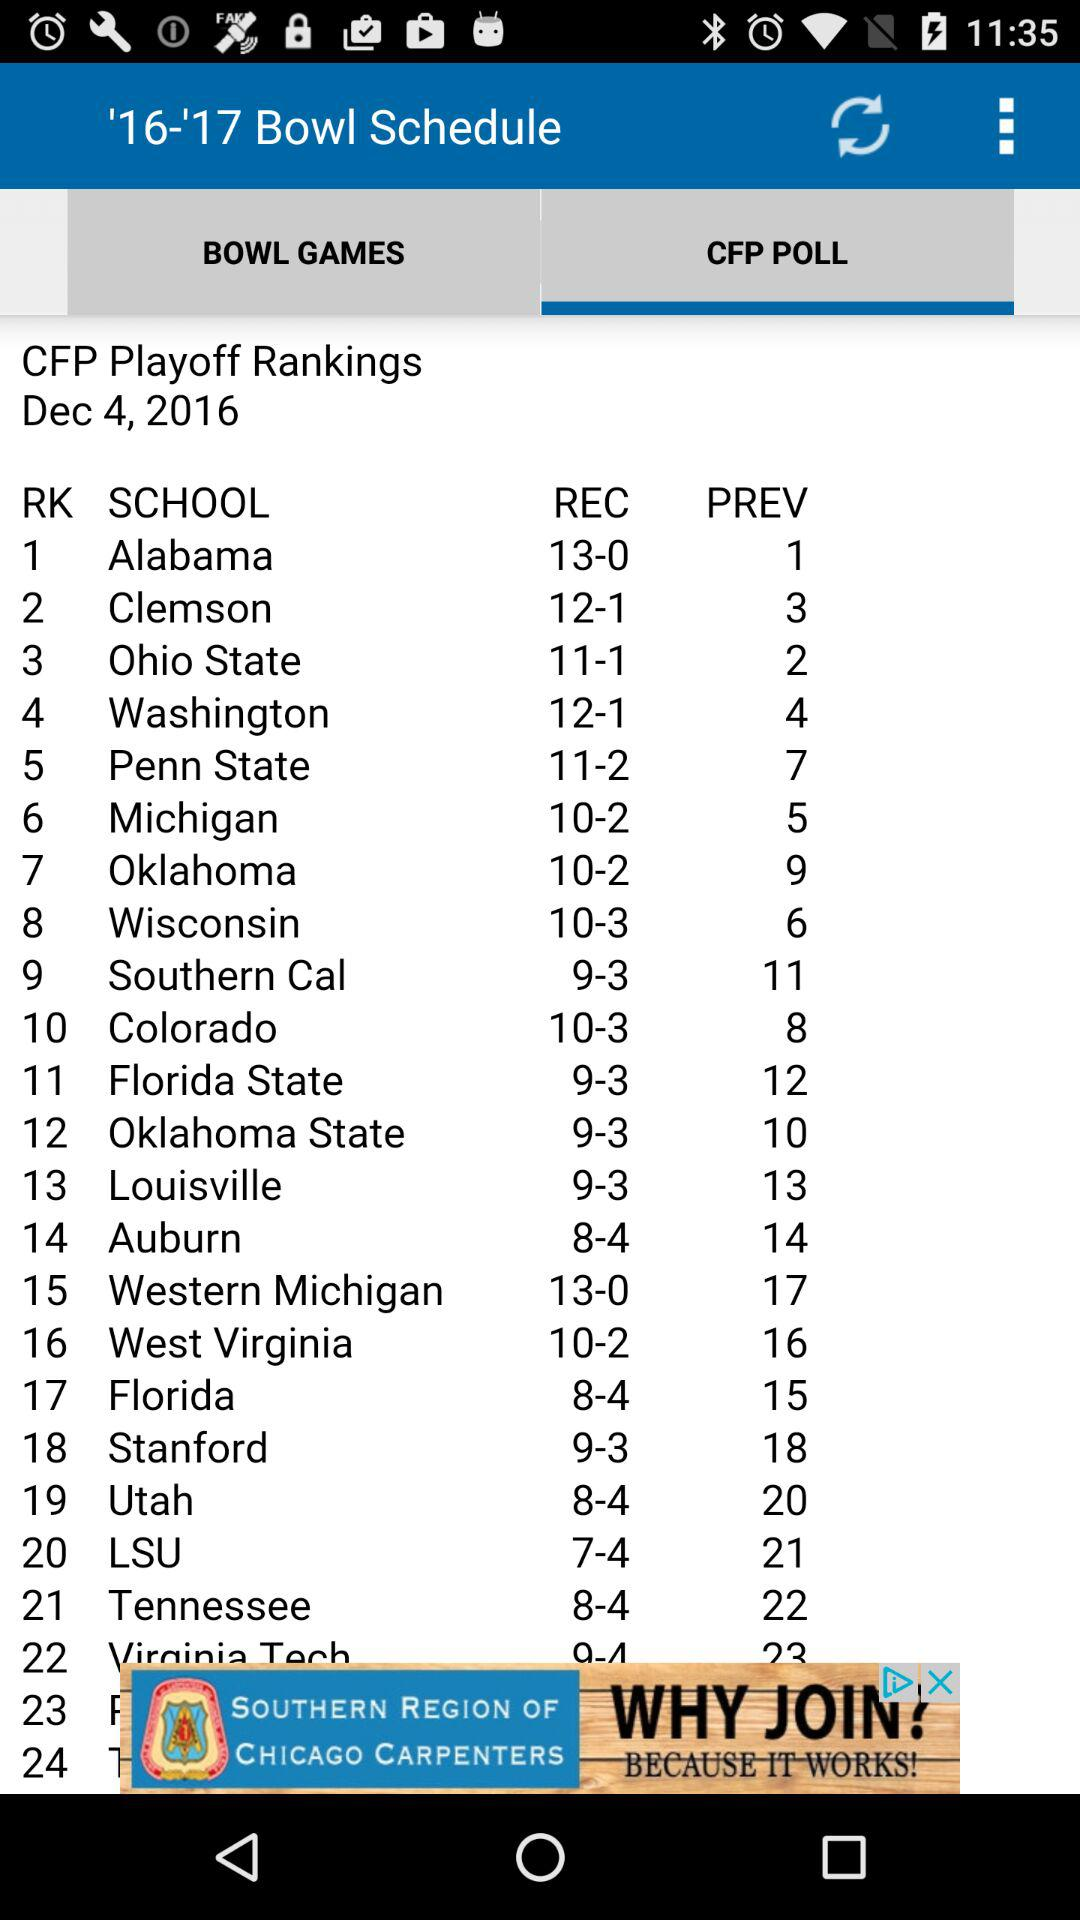What is the selected date? The selected date is December 4, 2016. 